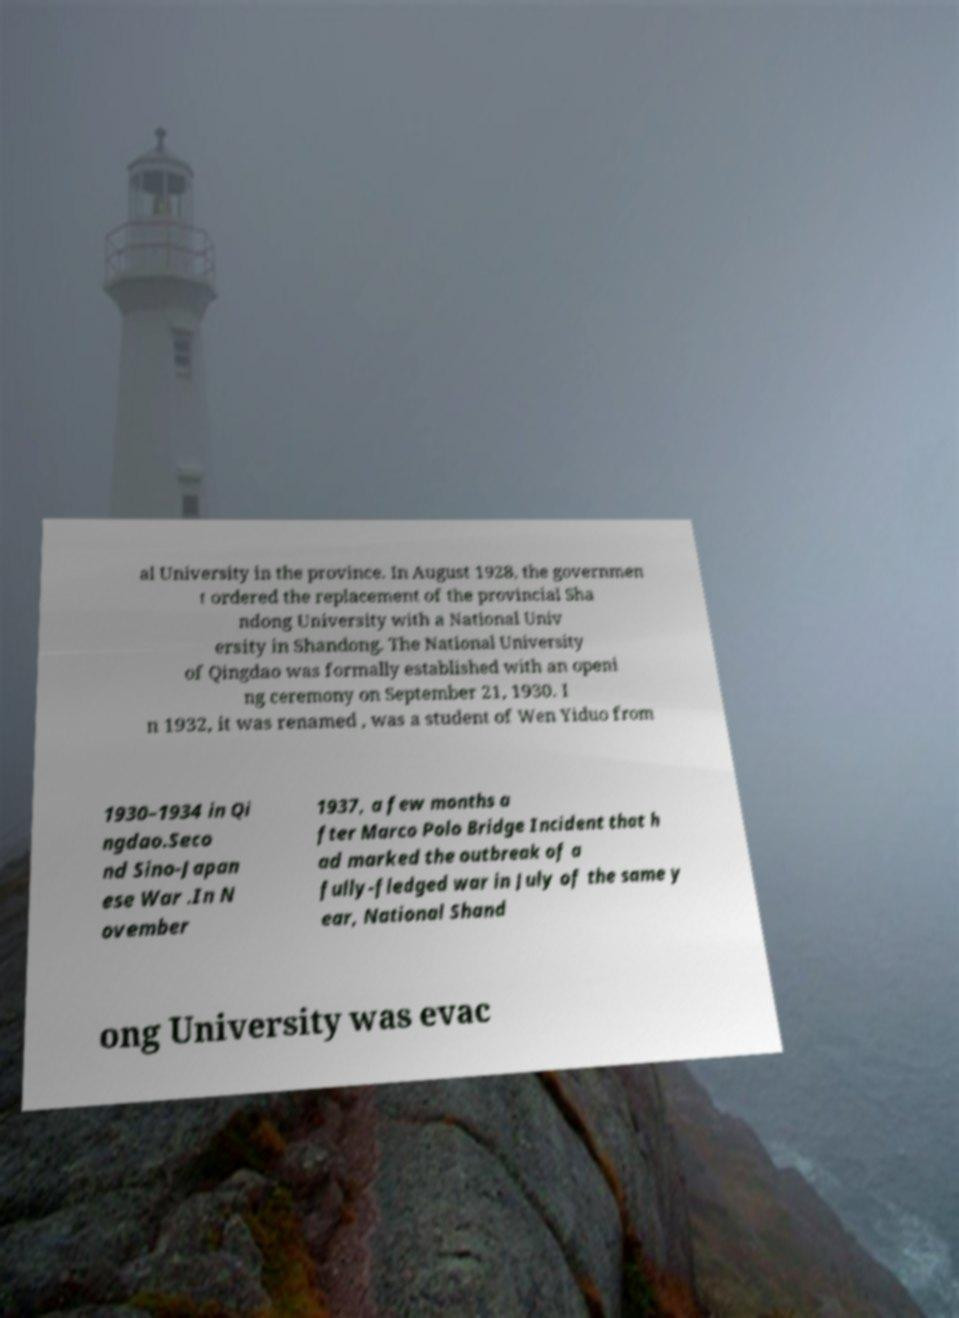Can you read and provide the text displayed in the image?This photo seems to have some interesting text. Can you extract and type it out for me? al University in the province. In August 1928, the governmen t ordered the replacement of the provincial Sha ndong University with a National Univ ersity in Shandong. The National University of Qingdao was formally established with an openi ng ceremony on September 21, 1930. I n 1932, it was renamed , was a student of Wen Yiduo from 1930–1934 in Qi ngdao.Seco nd Sino-Japan ese War .In N ovember 1937, a few months a fter Marco Polo Bridge Incident that h ad marked the outbreak of a fully-fledged war in July of the same y ear, National Shand ong University was evac 